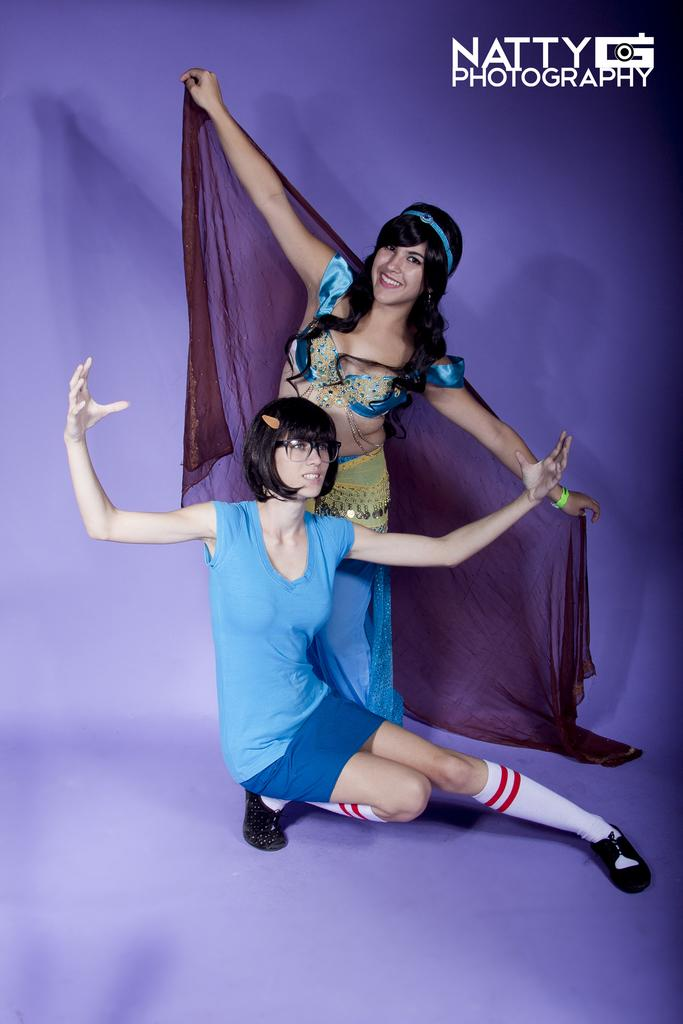How many people are in the image? There are two girls in the image. What are the girls doing in the image? The girls are in a dancing pose. Is there any text or logo on the image? Yes, there is a watermark on the image. What type of smile can be seen on the girls' faces in the image? There is no information about the girls' facial expressions in the provided facts, so we cannot determine if they are smiling or not. 